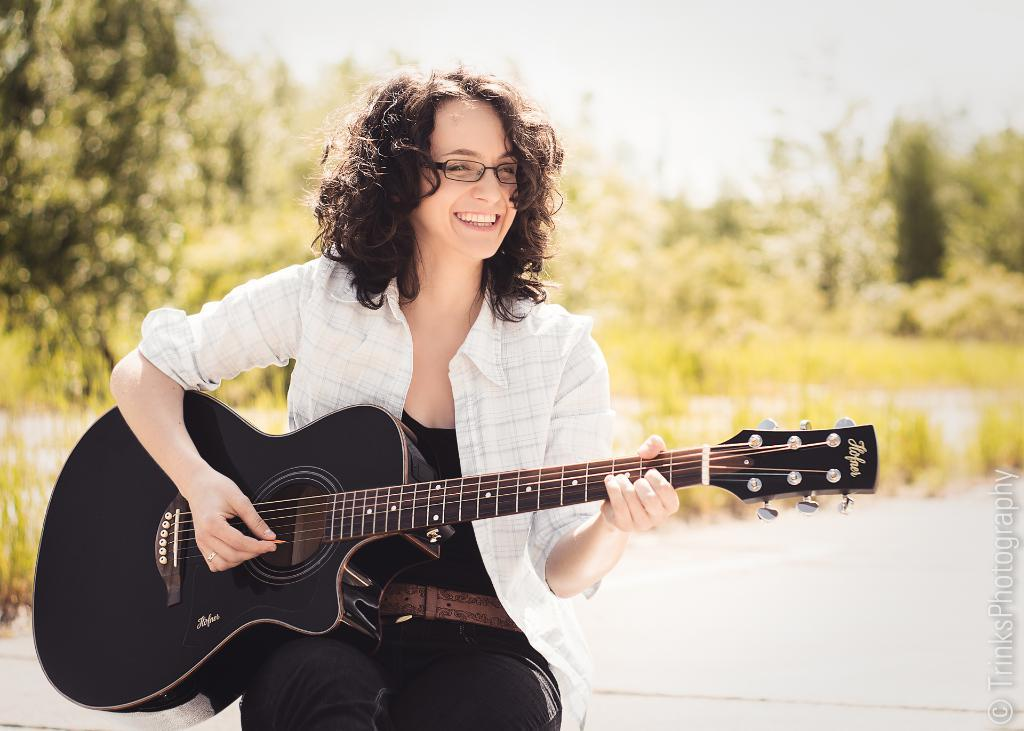Who is the main subject in the image? There is a woman in the image. What is the woman doing in the image? The woman is playing a guitar. What can be seen in the background of the image? The background of the image includes grass and trees. Can you see any bread in the image? There is no bread present in the image. Does the woman have any fangs while playing the guitar? There is no indication of fangs on the woman in the image. 